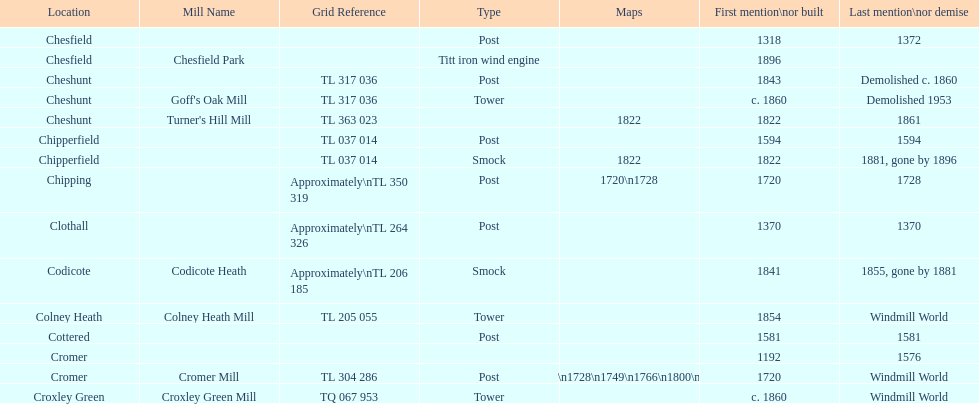Did cromer, chipperfield or cheshunt have the most windmills? Cheshunt. 